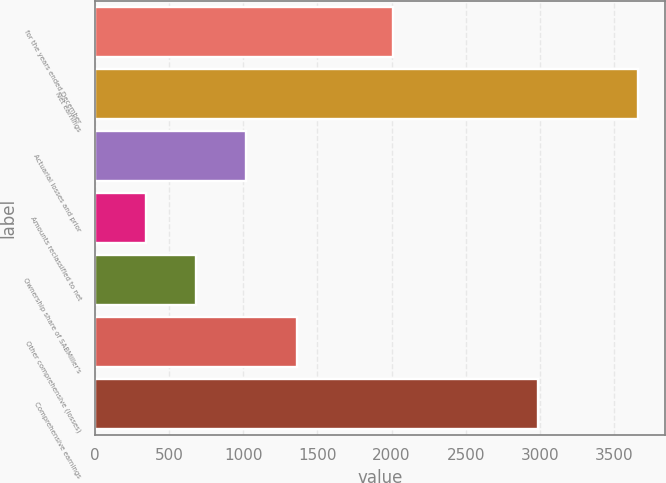Convert chart. <chart><loc_0><loc_0><loc_500><loc_500><bar_chart><fcel>for the years ended December<fcel>Net earnings<fcel>Actuarial losses and prior<fcel>Amounts reclassified to net<fcel>Ownership share of SABMiller's<fcel>Other comprehensive (losses)<fcel>Comprehensive earnings<nl><fcel>2011<fcel>3665<fcel>1020<fcel>342<fcel>681<fcel>1359<fcel>2987<nl></chart> 